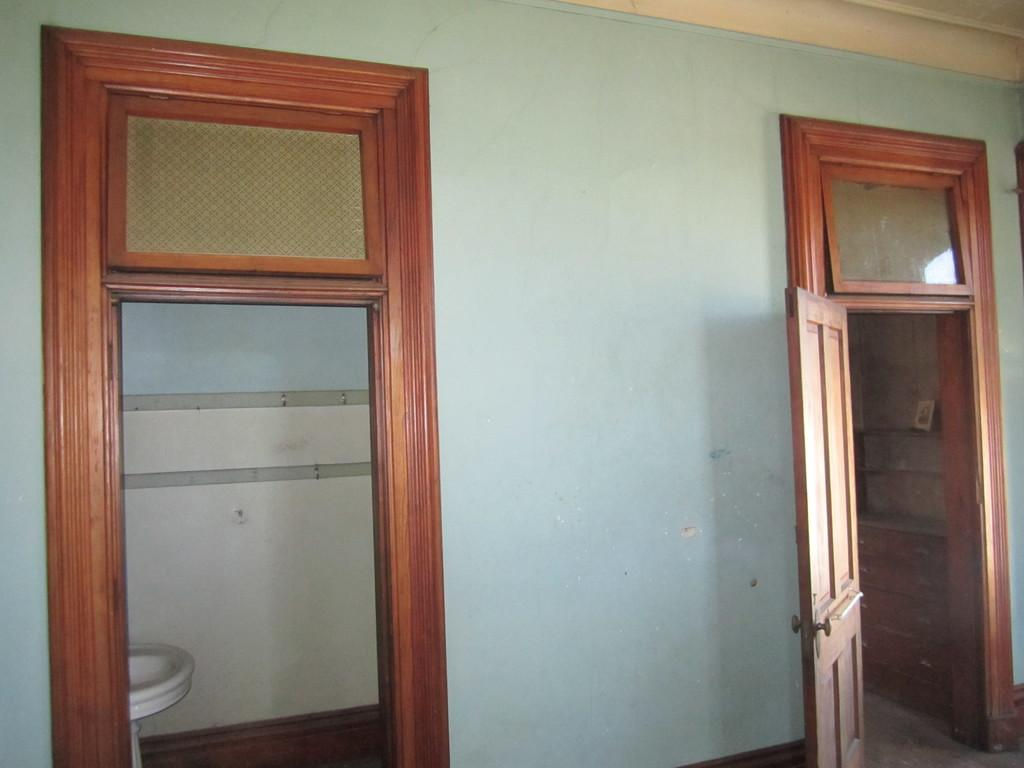What type of structure can be seen in the image? There is a wall in the image. Are there any openings in the wall? Yes, there are doors in the image. What can be found near the doors? There is a wash basin visible in the image. Is there any decorative item in the image? Yes, there is a photo frame in the image. Where might this image have been taken? The image is likely taken in a room. How many clocks can be seen hanging on the wall in the image? There are no clocks visible in the image; only a wall, doors, a wash basin, and a photo frame are present. 